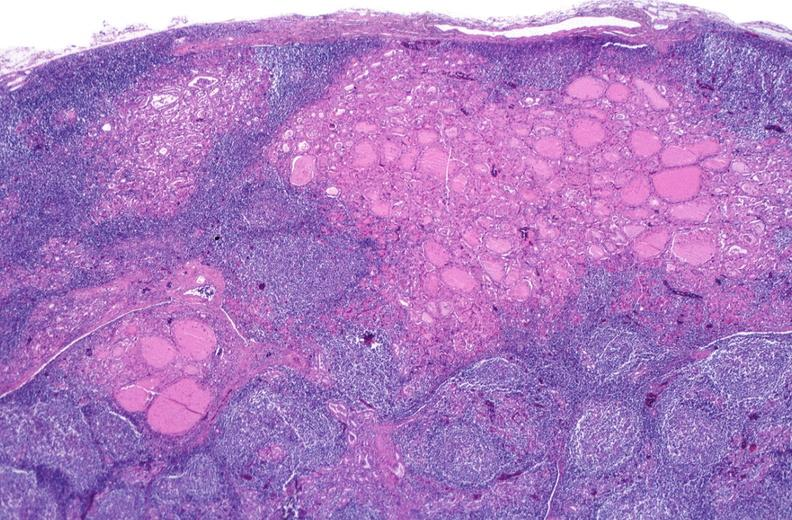does this image show hashimoto 's thyroiditis?
Answer the question using a single word or phrase. Yes 